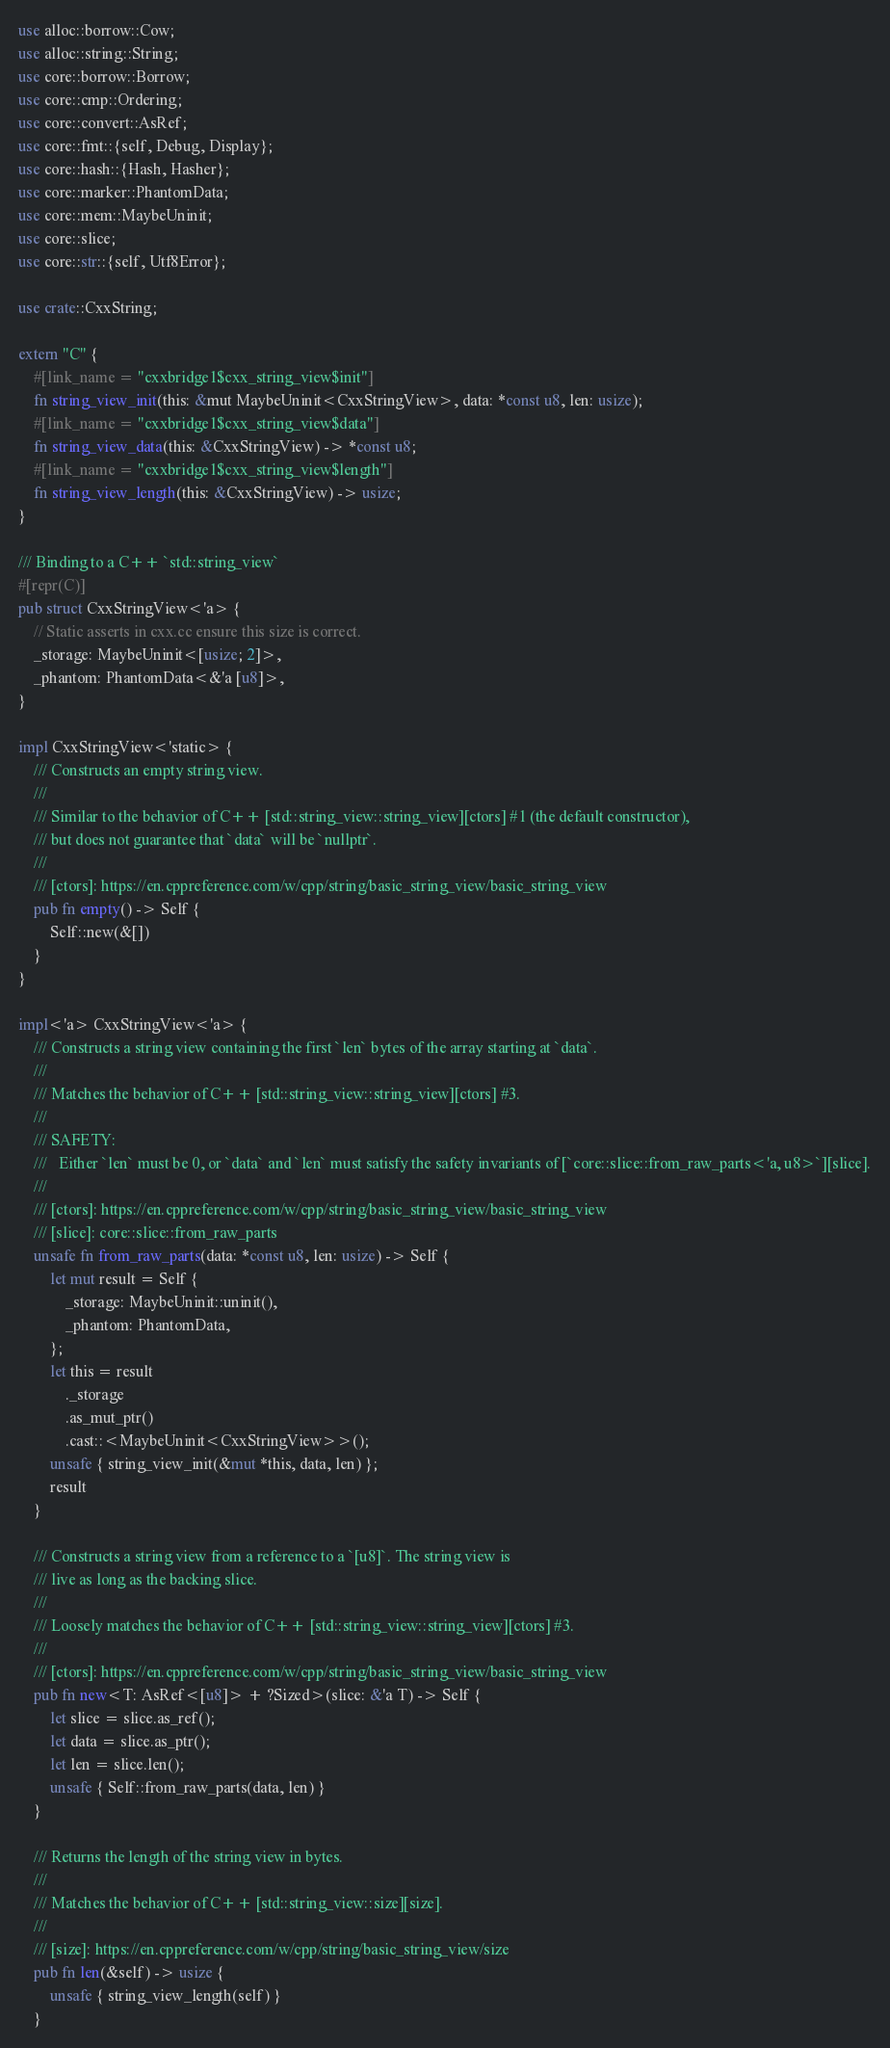Convert code to text. <code><loc_0><loc_0><loc_500><loc_500><_Rust_>use alloc::borrow::Cow;
use alloc::string::String;
use core::borrow::Borrow;
use core::cmp::Ordering;
use core::convert::AsRef;
use core::fmt::{self, Debug, Display};
use core::hash::{Hash, Hasher};
use core::marker::PhantomData;
use core::mem::MaybeUninit;
use core::slice;
use core::str::{self, Utf8Error};

use crate::CxxString;

extern "C" {
    #[link_name = "cxxbridge1$cxx_string_view$init"]
    fn string_view_init(this: &mut MaybeUninit<CxxStringView>, data: *const u8, len: usize);
    #[link_name = "cxxbridge1$cxx_string_view$data"]
    fn string_view_data(this: &CxxStringView) -> *const u8;
    #[link_name = "cxxbridge1$cxx_string_view$length"]
    fn string_view_length(this: &CxxStringView) -> usize;
}

/// Binding to a C++ `std::string_view`
#[repr(C)]
pub struct CxxStringView<'a> {
    // Static asserts in cxx.cc ensure this size is correct.
    _storage: MaybeUninit<[usize; 2]>,
    _phantom: PhantomData<&'a [u8]>,
}

impl CxxStringView<'static> {
    /// Constructs an empty string view.
    ///
    /// Similar to the behavior of C++ [std::string_view::string_view][ctors] #1 (the default constructor),
    /// but does not guarantee that `data` will be `nullptr`.
    ///
    /// [ctors]: https://en.cppreference.com/w/cpp/string/basic_string_view/basic_string_view
    pub fn empty() -> Self {
        Self::new(&[])
    }
}

impl<'a> CxxStringView<'a> {
    /// Constructs a string view containing the first `len` bytes of the array starting at `data`.
    ///
    /// Matches the behavior of C++ [std::string_view::string_view][ctors] #3.
    ///
    /// SAFETY:
    ///   Either `len` must be 0, or `data` and `len` must satisfy the safety invariants of [`core::slice::from_raw_parts<'a, u8>`][slice].
    ///
    /// [ctors]: https://en.cppreference.com/w/cpp/string/basic_string_view/basic_string_view
    /// [slice]: core::slice::from_raw_parts
    unsafe fn from_raw_parts(data: *const u8, len: usize) -> Self {
        let mut result = Self {
            _storage: MaybeUninit::uninit(),
            _phantom: PhantomData,
        };
        let this = result
            ._storage
            .as_mut_ptr()
            .cast::<MaybeUninit<CxxStringView>>();
        unsafe { string_view_init(&mut *this, data, len) };
        result
    }

    /// Constructs a string view from a reference to a `[u8]`. The string view is
    /// live as long as the backing slice.
    ///
    /// Loosely matches the behavior of C++ [std::string_view::string_view][ctors] #3.
    ///
    /// [ctors]: https://en.cppreference.com/w/cpp/string/basic_string_view/basic_string_view
    pub fn new<T: AsRef<[u8]> + ?Sized>(slice: &'a T) -> Self {
        let slice = slice.as_ref();
        let data = slice.as_ptr();
        let len = slice.len();
        unsafe { Self::from_raw_parts(data, len) }
    }

    /// Returns the length of the string view in bytes.
    ///
    /// Matches the behavior of C++ [std::string_view::size][size].
    ///
    /// [size]: https://en.cppreference.com/w/cpp/string/basic_string_view/size
    pub fn len(&self) -> usize {
        unsafe { string_view_length(self) }
    }
</code> 